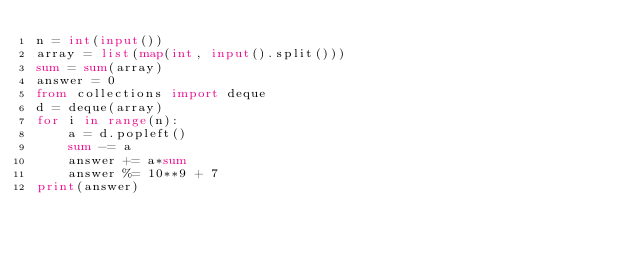Convert code to text. <code><loc_0><loc_0><loc_500><loc_500><_Python_>n = int(input())
array = list(map(int, input().split()))
sum = sum(array)
answer = 0
from collections import deque
d = deque(array)
for i in range(n):
    a = d.popleft()
    sum -= a
    answer += a*sum
    answer %= 10**9 + 7
print(answer)</code> 